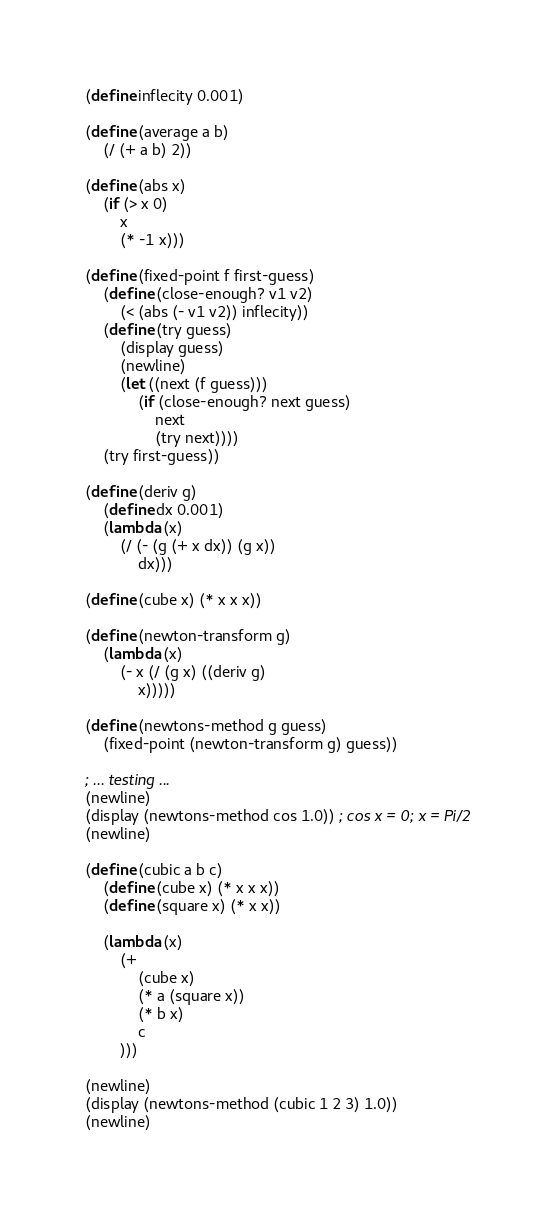<code> <loc_0><loc_0><loc_500><loc_500><_Scheme_>(define inflecity 0.001)

(define (average a b)
    (/ (+ a b) 2))

(define (abs x)
    (if (> x 0) 
        x
        (* -1 x)))

(define (fixed-point f first-guess)
    (define (close-enough? v1 v2)
        (< (abs (- v1 v2)) inflecity))
    (define (try guess)
        (display guess)
        (newline)
        (let ((next (f guess))) 
            (if (close-enough? next guess) 
                next
                (try next))))
    (try first-guess))

(define (deriv g)
    (define dx 0.001)
    (lambda (x)
        (/ (- (g (+ x dx)) (g x)) 
            dx)))

(define (cube x) (* x x x))

(define (newton-transform g)
    (lambda (x)
        (- x (/ (g x) ((deriv g) 
            x)))))

(define (newtons-method g guess)
    (fixed-point (newton-transform g) guess))

; ... testing ...
(newline)
(display (newtons-method cos 1.0)) ; cos x = 0; x = Pi/2
(newline)

(define (cubic a b c)
    (define (cube x) (* x x x))
    (define (square x) (* x x))

    (lambda (x)
        (+ 
            (cube x) 
            (* a (square x)) 
            (* b x) 
            c
        )))

(newline)
(display (newtons-method (cubic 1 2 3) 1.0))
(newline)






</code> 